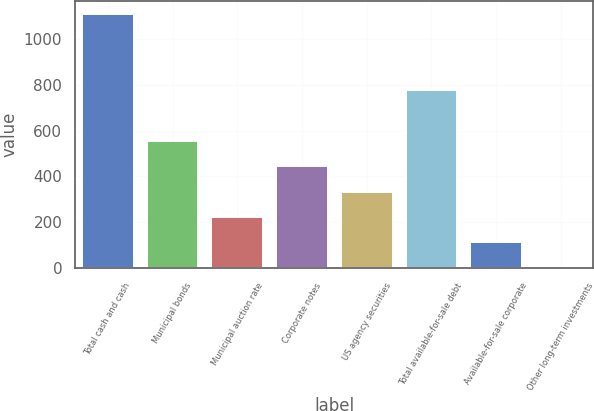Convert chart to OTSL. <chart><loc_0><loc_0><loc_500><loc_500><bar_chart><fcel>Total cash and cash<fcel>Municipal bonds<fcel>Municipal auction rate<fcel>Corporate notes<fcel>US agency securities<fcel>Total available-for-sale debt<fcel>Available-for-sale corporate<fcel>Other long-term investments<nl><fcel>1109<fcel>555<fcel>222.6<fcel>444.2<fcel>333.4<fcel>776.6<fcel>111.8<fcel>1<nl></chart> 